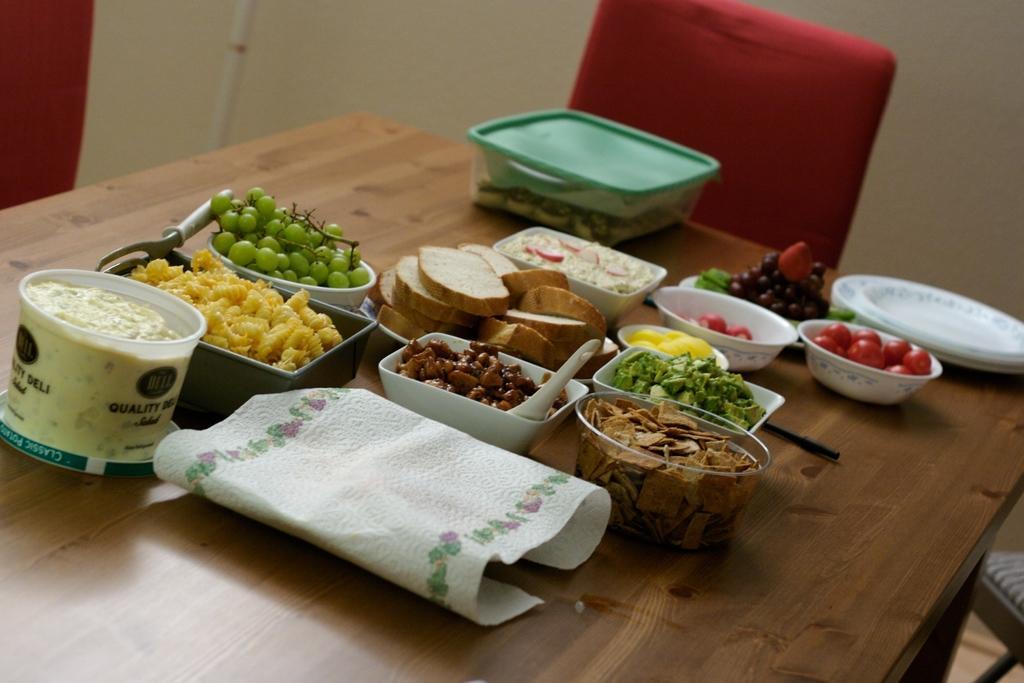Please provide a concise description of this image. In this picture I can see some fruits, food items in the balls are placed on the table, side I can see some chairs. 